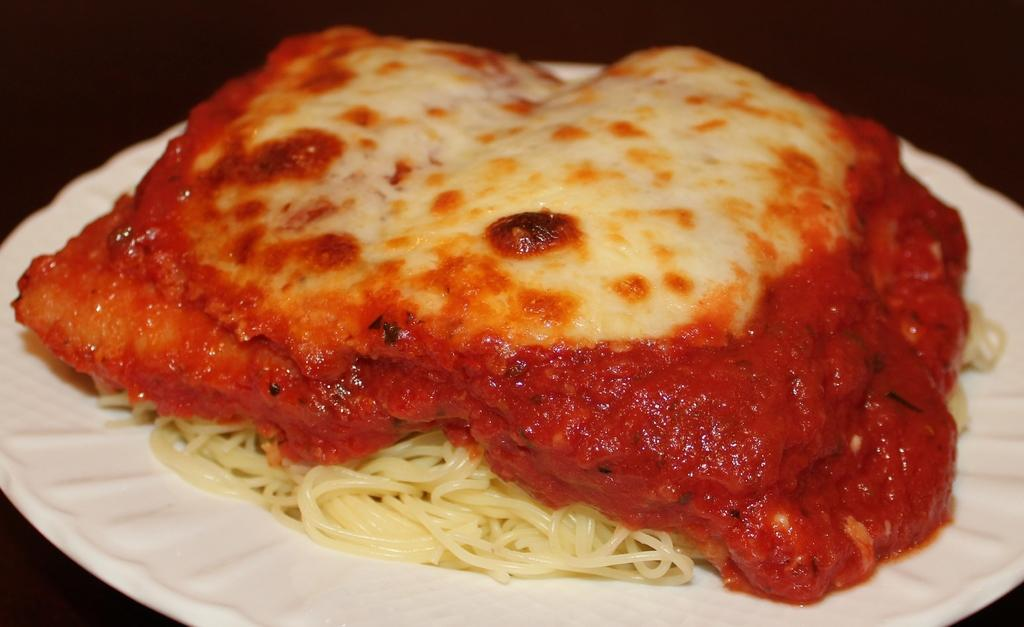What is present on the plate in the image? There are food items on the plate in the image. Can you describe the background of the image? The background of the image is dark. What hobbies are the food items participating in within the image? Food items do not have hobbies, as they are inanimate objects. 